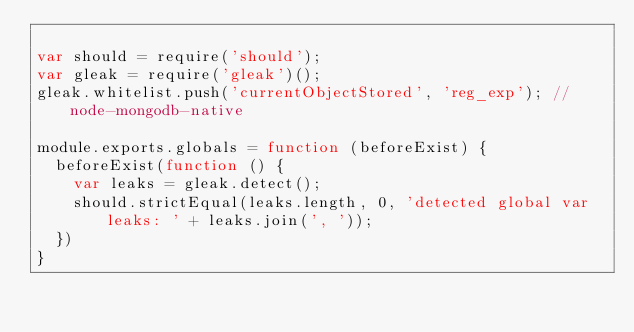Convert code to text. <code><loc_0><loc_0><loc_500><loc_500><_JavaScript_>
var should = require('should');
var gleak = require('gleak')();
gleak.whitelist.push('currentObjectStored', 'reg_exp'); // node-mongodb-native

module.exports.globals = function (beforeExist) {
  beforeExist(function () {
    var leaks = gleak.detect();
    should.strictEqual(leaks.length, 0, 'detected global var leaks: ' + leaks.join(', '));
  })
}
</code> 